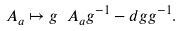Convert formula to latex. <formula><loc_0><loc_0><loc_500><loc_500>\ A _ { a } \mapsto g \ A _ { a } g ^ { - 1 } - d g g ^ { - 1 } .</formula> 